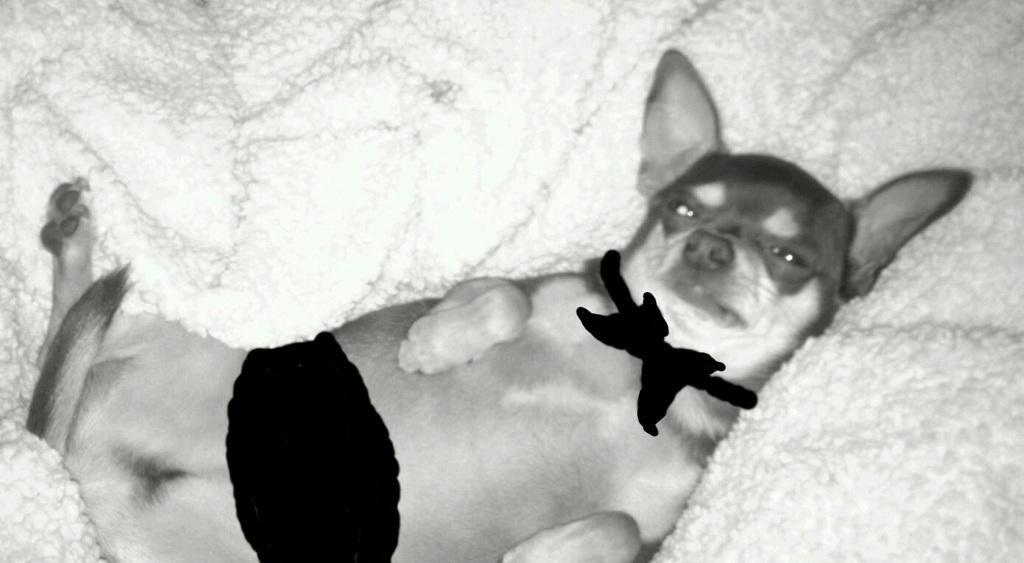In one or two sentences, can you explain what this image depicts? In this image we can see a dog lying on a white object. There are some black animated marks on the dog. 